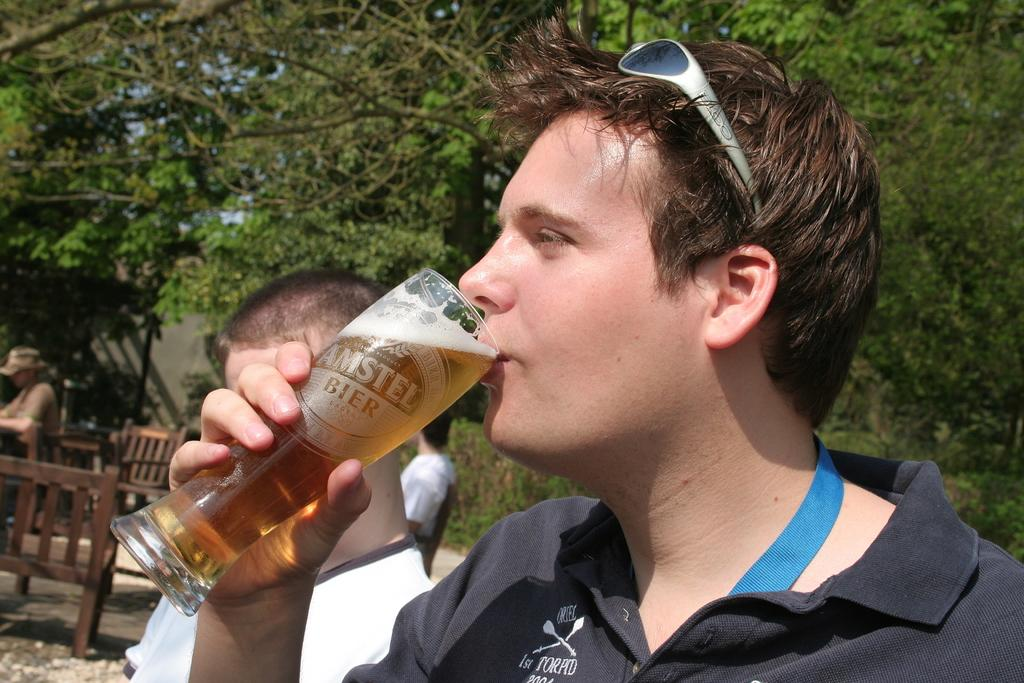Who is the main subject in the image? There is a man in the image. What is the man doing in the image? The man is drinking a glass of wine. What can be seen in the background of the image? There are people, trees, chairs, and a table in the background of the image. What type of metal is used to make the salt shaker on the table in the image? There is no salt shaker present in the image, so it is not possible to determine the type of metal used. 